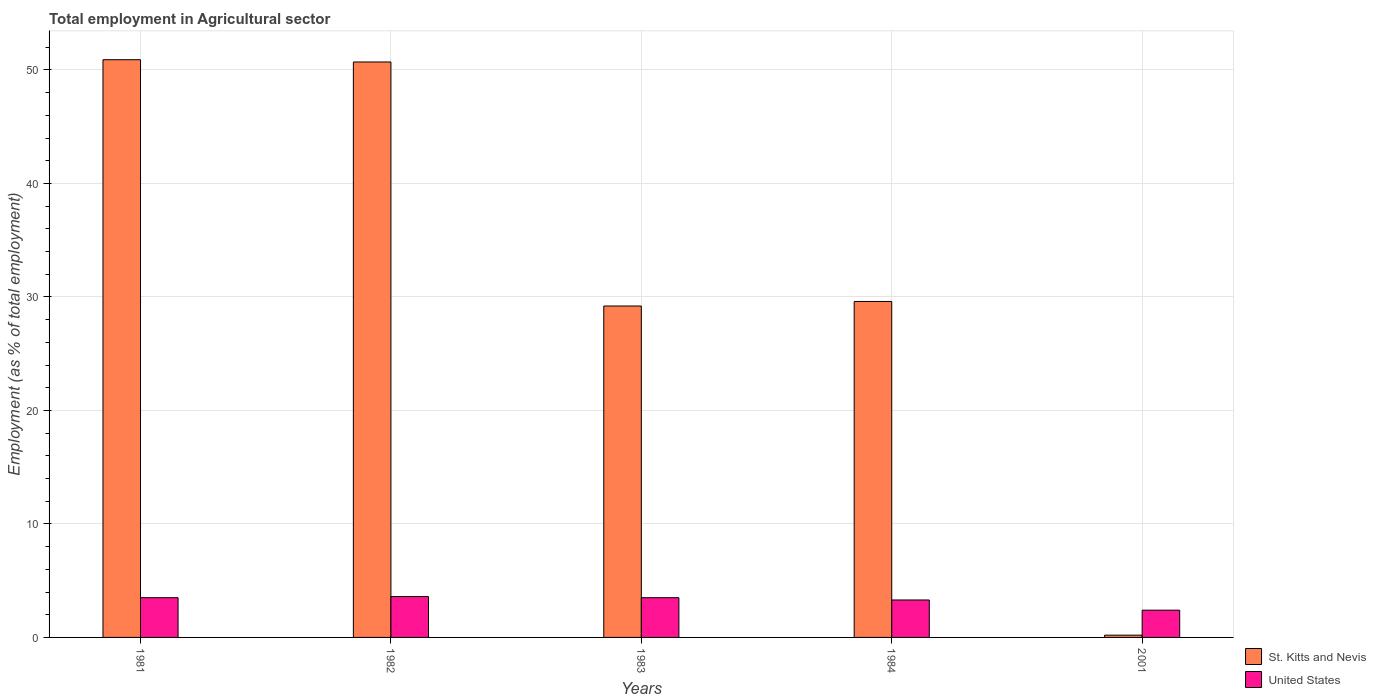How many different coloured bars are there?
Your response must be concise. 2. How many groups of bars are there?
Make the answer very short. 5. Are the number of bars on each tick of the X-axis equal?
Keep it short and to the point. Yes. How many bars are there on the 3rd tick from the right?
Keep it short and to the point. 2. What is the label of the 5th group of bars from the left?
Your answer should be compact. 2001. What is the employment in agricultural sector in United States in 2001?
Give a very brief answer. 2.4. Across all years, what is the maximum employment in agricultural sector in United States?
Keep it short and to the point. 3.6. Across all years, what is the minimum employment in agricultural sector in St. Kitts and Nevis?
Your response must be concise. 0.2. In which year was the employment in agricultural sector in United States minimum?
Your answer should be compact. 2001. What is the total employment in agricultural sector in St. Kitts and Nevis in the graph?
Provide a short and direct response. 160.6. What is the difference between the employment in agricultural sector in St. Kitts and Nevis in 1983 and that in 2001?
Provide a succinct answer. 29. What is the difference between the employment in agricultural sector in United States in 1981 and the employment in agricultural sector in St. Kitts and Nevis in 2001?
Your answer should be very brief. 3.3. What is the average employment in agricultural sector in St. Kitts and Nevis per year?
Ensure brevity in your answer.  32.12. In the year 2001, what is the difference between the employment in agricultural sector in United States and employment in agricultural sector in St. Kitts and Nevis?
Offer a terse response. 2.2. In how many years, is the employment in agricultural sector in St. Kitts and Nevis greater than 28 %?
Make the answer very short. 4. What is the ratio of the employment in agricultural sector in United States in 1982 to that in 1983?
Your answer should be very brief. 1.03. Is the employment in agricultural sector in St. Kitts and Nevis in 1984 less than that in 2001?
Ensure brevity in your answer.  No. What is the difference between the highest and the second highest employment in agricultural sector in United States?
Your response must be concise. 0.1. What is the difference between the highest and the lowest employment in agricultural sector in St. Kitts and Nevis?
Keep it short and to the point. 50.7. In how many years, is the employment in agricultural sector in United States greater than the average employment in agricultural sector in United States taken over all years?
Provide a succinct answer. 4. What does the 2nd bar from the left in 2001 represents?
Give a very brief answer. United States. What does the 2nd bar from the right in 2001 represents?
Offer a very short reply. St. Kitts and Nevis. How many bars are there?
Make the answer very short. 10. What is the difference between two consecutive major ticks on the Y-axis?
Ensure brevity in your answer.  10. Does the graph contain any zero values?
Offer a terse response. No. Does the graph contain grids?
Keep it short and to the point. Yes. Where does the legend appear in the graph?
Give a very brief answer. Bottom right. How are the legend labels stacked?
Provide a short and direct response. Vertical. What is the title of the graph?
Your answer should be very brief. Total employment in Agricultural sector. What is the label or title of the X-axis?
Provide a short and direct response. Years. What is the label or title of the Y-axis?
Offer a very short reply. Employment (as % of total employment). What is the Employment (as % of total employment) in St. Kitts and Nevis in 1981?
Provide a succinct answer. 50.9. What is the Employment (as % of total employment) in United States in 1981?
Your answer should be very brief. 3.5. What is the Employment (as % of total employment) in St. Kitts and Nevis in 1982?
Your answer should be compact. 50.7. What is the Employment (as % of total employment) in United States in 1982?
Provide a succinct answer. 3.6. What is the Employment (as % of total employment) in St. Kitts and Nevis in 1983?
Provide a short and direct response. 29.2. What is the Employment (as % of total employment) in United States in 1983?
Your answer should be very brief. 3.5. What is the Employment (as % of total employment) in St. Kitts and Nevis in 1984?
Make the answer very short. 29.6. What is the Employment (as % of total employment) of United States in 1984?
Your answer should be compact. 3.3. What is the Employment (as % of total employment) of St. Kitts and Nevis in 2001?
Make the answer very short. 0.2. What is the Employment (as % of total employment) of United States in 2001?
Provide a succinct answer. 2.4. Across all years, what is the maximum Employment (as % of total employment) of St. Kitts and Nevis?
Provide a short and direct response. 50.9. Across all years, what is the maximum Employment (as % of total employment) of United States?
Your response must be concise. 3.6. Across all years, what is the minimum Employment (as % of total employment) of St. Kitts and Nevis?
Make the answer very short. 0.2. Across all years, what is the minimum Employment (as % of total employment) in United States?
Provide a succinct answer. 2.4. What is the total Employment (as % of total employment) of St. Kitts and Nevis in the graph?
Keep it short and to the point. 160.6. What is the difference between the Employment (as % of total employment) of St. Kitts and Nevis in 1981 and that in 1982?
Your answer should be very brief. 0.2. What is the difference between the Employment (as % of total employment) of St. Kitts and Nevis in 1981 and that in 1983?
Your answer should be compact. 21.7. What is the difference between the Employment (as % of total employment) of United States in 1981 and that in 1983?
Offer a very short reply. 0. What is the difference between the Employment (as % of total employment) of St. Kitts and Nevis in 1981 and that in 1984?
Provide a short and direct response. 21.3. What is the difference between the Employment (as % of total employment) in United States in 1981 and that in 1984?
Keep it short and to the point. 0.2. What is the difference between the Employment (as % of total employment) in St. Kitts and Nevis in 1981 and that in 2001?
Make the answer very short. 50.7. What is the difference between the Employment (as % of total employment) in United States in 1981 and that in 2001?
Keep it short and to the point. 1.1. What is the difference between the Employment (as % of total employment) in St. Kitts and Nevis in 1982 and that in 1984?
Keep it short and to the point. 21.1. What is the difference between the Employment (as % of total employment) of United States in 1982 and that in 1984?
Your response must be concise. 0.3. What is the difference between the Employment (as % of total employment) of St. Kitts and Nevis in 1982 and that in 2001?
Keep it short and to the point. 50.5. What is the difference between the Employment (as % of total employment) in St. Kitts and Nevis in 1983 and that in 2001?
Offer a very short reply. 29. What is the difference between the Employment (as % of total employment) in St. Kitts and Nevis in 1984 and that in 2001?
Offer a very short reply. 29.4. What is the difference between the Employment (as % of total employment) in St. Kitts and Nevis in 1981 and the Employment (as % of total employment) in United States in 1982?
Make the answer very short. 47.3. What is the difference between the Employment (as % of total employment) in St. Kitts and Nevis in 1981 and the Employment (as % of total employment) in United States in 1983?
Your answer should be very brief. 47.4. What is the difference between the Employment (as % of total employment) in St. Kitts and Nevis in 1981 and the Employment (as % of total employment) in United States in 1984?
Provide a succinct answer. 47.6. What is the difference between the Employment (as % of total employment) of St. Kitts and Nevis in 1981 and the Employment (as % of total employment) of United States in 2001?
Your response must be concise. 48.5. What is the difference between the Employment (as % of total employment) in St. Kitts and Nevis in 1982 and the Employment (as % of total employment) in United States in 1983?
Offer a very short reply. 47.2. What is the difference between the Employment (as % of total employment) in St. Kitts and Nevis in 1982 and the Employment (as % of total employment) in United States in 1984?
Your answer should be very brief. 47.4. What is the difference between the Employment (as % of total employment) of St. Kitts and Nevis in 1982 and the Employment (as % of total employment) of United States in 2001?
Provide a short and direct response. 48.3. What is the difference between the Employment (as % of total employment) of St. Kitts and Nevis in 1983 and the Employment (as % of total employment) of United States in 1984?
Offer a terse response. 25.9. What is the difference between the Employment (as % of total employment) in St. Kitts and Nevis in 1983 and the Employment (as % of total employment) in United States in 2001?
Your response must be concise. 26.8. What is the difference between the Employment (as % of total employment) of St. Kitts and Nevis in 1984 and the Employment (as % of total employment) of United States in 2001?
Ensure brevity in your answer.  27.2. What is the average Employment (as % of total employment) in St. Kitts and Nevis per year?
Provide a short and direct response. 32.12. What is the average Employment (as % of total employment) of United States per year?
Offer a very short reply. 3.26. In the year 1981, what is the difference between the Employment (as % of total employment) in St. Kitts and Nevis and Employment (as % of total employment) in United States?
Provide a succinct answer. 47.4. In the year 1982, what is the difference between the Employment (as % of total employment) in St. Kitts and Nevis and Employment (as % of total employment) in United States?
Offer a terse response. 47.1. In the year 1983, what is the difference between the Employment (as % of total employment) of St. Kitts and Nevis and Employment (as % of total employment) of United States?
Make the answer very short. 25.7. In the year 1984, what is the difference between the Employment (as % of total employment) in St. Kitts and Nevis and Employment (as % of total employment) in United States?
Provide a short and direct response. 26.3. In the year 2001, what is the difference between the Employment (as % of total employment) in St. Kitts and Nevis and Employment (as % of total employment) in United States?
Your answer should be compact. -2.2. What is the ratio of the Employment (as % of total employment) in St. Kitts and Nevis in 1981 to that in 1982?
Your answer should be compact. 1. What is the ratio of the Employment (as % of total employment) of United States in 1981 to that in 1982?
Provide a short and direct response. 0.97. What is the ratio of the Employment (as % of total employment) in St. Kitts and Nevis in 1981 to that in 1983?
Offer a very short reply. 1.74. What is the ratio of the Employment (as % of total employment) in St. Kitts and Nevis in 1981 to that in 1984?
Provide a short and direct response. 1.72. What is the ratio of the Employment (as % of total employment) in United States in 1981 to that in 1984?
Your answer should be very brief. 1.06. What is the ratio of the Employment (as % of total employment) in St. Kitts and Nevis in 1981 to that in 2001?
Your answer should be very brief. 254.5. What is the ratio of the Employment (as % of total employment) of United States in 1981 to that in 2001?
Provide a succinct answer. 1.46. What is the ratio of the Employment (as % of total employment) in St. Kitts and Nevis in 1982 to that in 1983?
Your answer should be very brief. 1.74. What is the ratio of the Employment (as % of total employment) in United States in 1982 to that in 1983?
Offer a very short reply. 1.03. What is the ratio of the Employment (as % of total employment) of St. Kitts and Nevis in 1982 to that in 1984?
Your answer should be very brief. 1.71. What is the ratio of the Employment (as % of total employment) of St. Kitts and Nevis in 1982 to that in 2001?
Ensure brevity in your answer.  253.5. What is the ratio of the Employment (as % of total employment) of United States in 1982 to that in 2001?
Offer a terse response. 1.5. What is the ratio of the Employment (as % of total employment) of St. Kitts and Nevis in 1983 to that in 1984?
Your answer should be very brief. 0.99. What is the ratio of the Employment (as % of total employment) in United States in 1983 to that in 1984?
Make the answer very short. 1.06. What is the ratio of the Employment (as % of total employment) of St. Kitts and Nevis in 1983 to that in 2001?
Make the answer very short. 146. What is the ratio of the Employment (as % of total employment) in United States in 1983 to that in 2001?
Ensure brevity in your answer.  1.46. What is the ratio of the Employment (as % of total employment) of St. Kitts and Nevis in 1984 to that in 2001?
Ensure brevity in your answer.  148. What is the ratio of the Employment (as % of total employment) in United States in 1984 to that in 2001?
Ensure brevity in your answer.  1.38. What is the difference between the highest and the second highest Employment (as % of total employment) of St. Kitts and Nevis?
Offer a very short reply. 0.2. What is the difference between the highest and the second highest Employment (as % of total employment) in United States?
Give a very brief answer. 0.1. What is the difference between the highest and the lowest Employment (as % of total employment) of St. Kitts and Nevis?
Provide a succinct answer. 50.7. What is the difference between the highest and the lowest Employment (as % of total employment) of United States?
Ensure brevity in your answer.  1.2. 